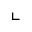<formula> <loc_0><loc_0><loc_500><loc_500>\llcorner</formula> 